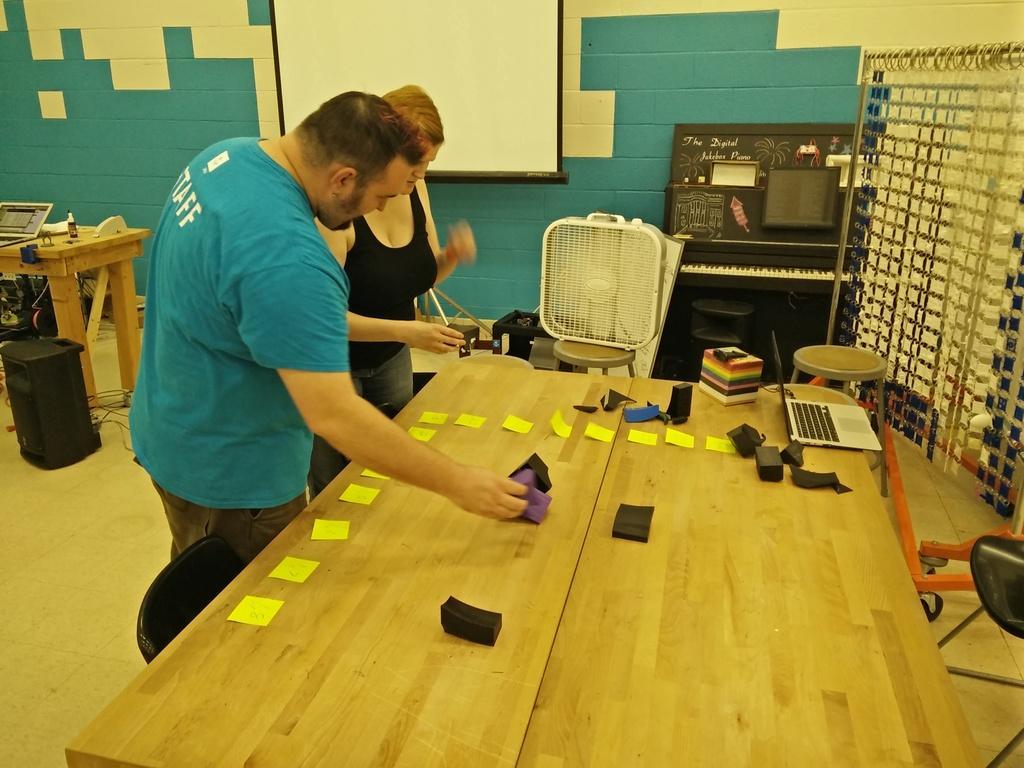Describe this image in one or two sentences. As we can see in the image there is a green color wall, screen, two people standing over here, chair and a table. On table there is a laptop and a box and there is a black color dustbin over here. 